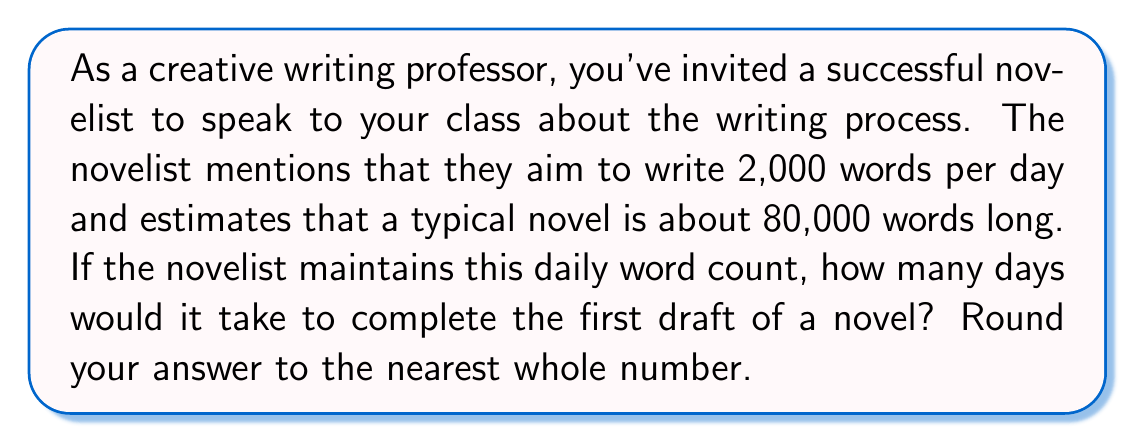Provide a solution to this math problem. To solve this problem, we need to follow these steps:

1. Identify the given information:
   - Daily word count goal: 2,000 words
   - Estimated length of a typical novel: 80,000 words

2. Set up the equation to calculate the number of days:
   Let $x$ be the number of days required.
   
   $$\text{Total words} = \text{Daily word count} \times \text{Number of days}$$
   $$80,000 = 2,000 \times x$$

3. Solve for $x$:
   $$x = \frac{80,000}{2,000}$$
   $$x = 40$$

4. Round to the nearest whole number:
   Since 40 is already a whole number, no rounding is necessary.

Therefore, it would take the novelist 40 days to complete the first draft of a novel at this pace.
Answer: 40 days 